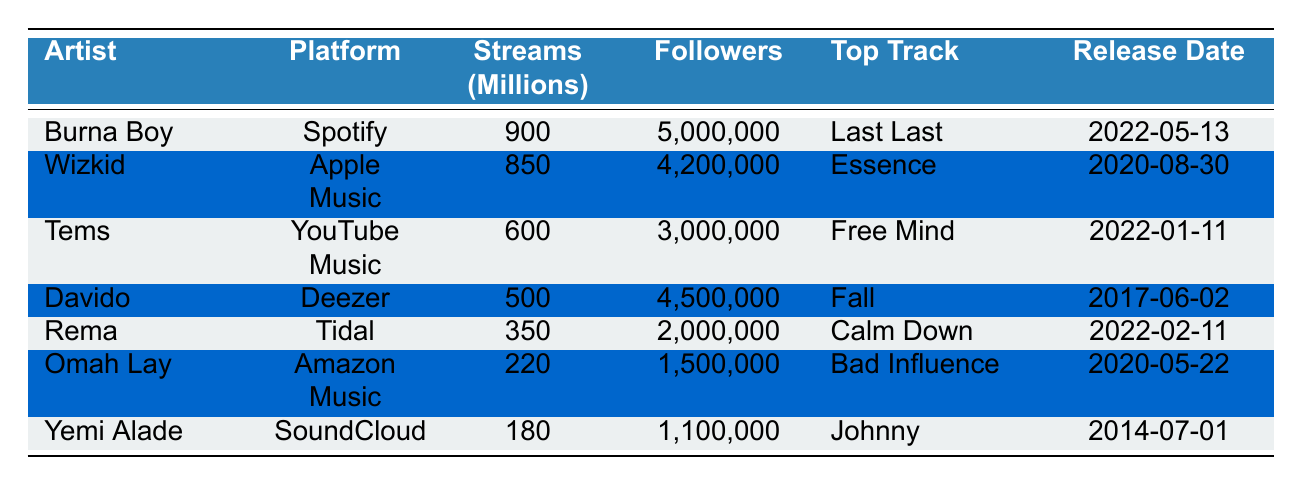What is Burna Boy's total stream count in millions? According to the table, Burna Boy has a total of 900 million streams.
Answer: 900 Which platform has the highest streams for a Nigerian artist? The table shows Burna Boy on Spotify with 900 million streams, which is the highest among all listed artists.
Answer: Spotify How many followers does Wizkid have? Wizkid has 4,200,000 followers as listed in the table.
Answer: 4,200,000 What is the total number of streams for Rema and Omah Lay combined? Rema has 350 million streams and Omah Lay has 220 million streams; when combined, their total is 350 + 220 = 570 million streams.
Answer: 570 Is Tems’ top track released after 2020? Tems’ top track "Free Mind" was released on January 11, 2022, which is after 2020.
Answer: Yes Which artist has the lowest stream count and what is it? The artist with the lowest streams in the table is Yemi Alade with 180 million streams.
Answer: Yemi Alade, 180 million What artist has a top track released in 2017, and what is the track's name? The table shows that Davido's top track "Fall" was released on June 2, 2017.
Answer: Davido, Fall What is the average number of followers for the listed artists? The total number of followers is 5,000,000 + 4,200,000 + 3,000,000 + 4,500,000 + 2,000,000 + 1,500,000 + 1,100,000 = 21,300,000; there are 7 artists, so the average is 21,300,000 / 7 = 3,042,857.
Answer: 3,042,857 Which artist's top track has the most recent release date? Analyzing the release dates, "Free Mind" by Tems (2022-01-11) is the most recent track released among all artists.
Answer: Tems How many streams does Davido have compared to Burna Boy? Davido has 500 million streams, which is 400 million less than Burna Boy who has 900 million streams.
Answer: 400 million less 